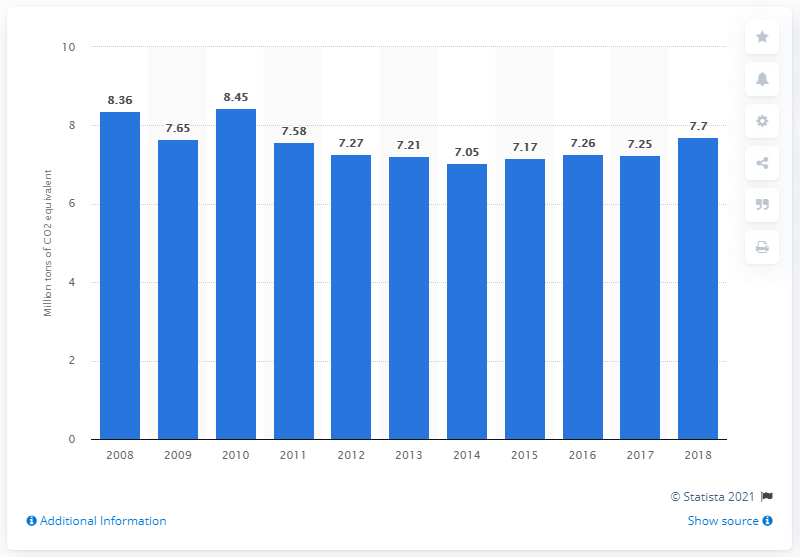Point out several critical features in this image. In 2018, the energy industries in Latvia produced approximately 7.7 million metric tons of CO2 equivalent. 